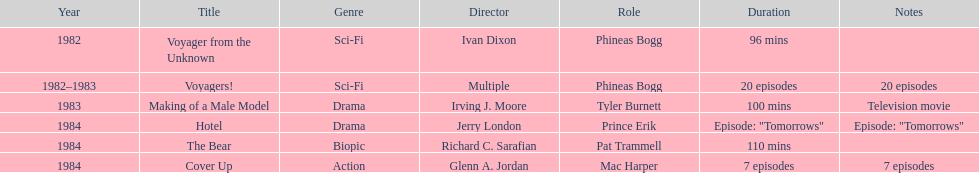Which year did he play the role of mac harper and also pat trammell? 1984. 